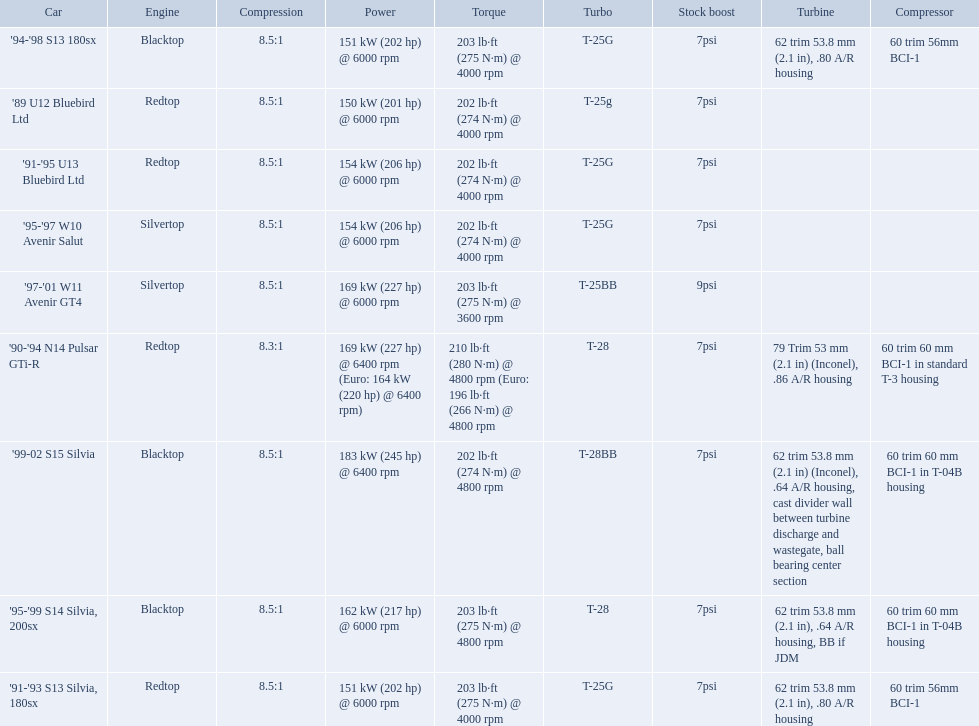What are the psi's? 7psi, 7psi, 7psi, 9psi, 7psi, 7psi, 7psi, 7psi, 7psi. What are the number(s) greater than 7? 9psi. Which car has that number? '97-'01 W11 Avenir GT4. 